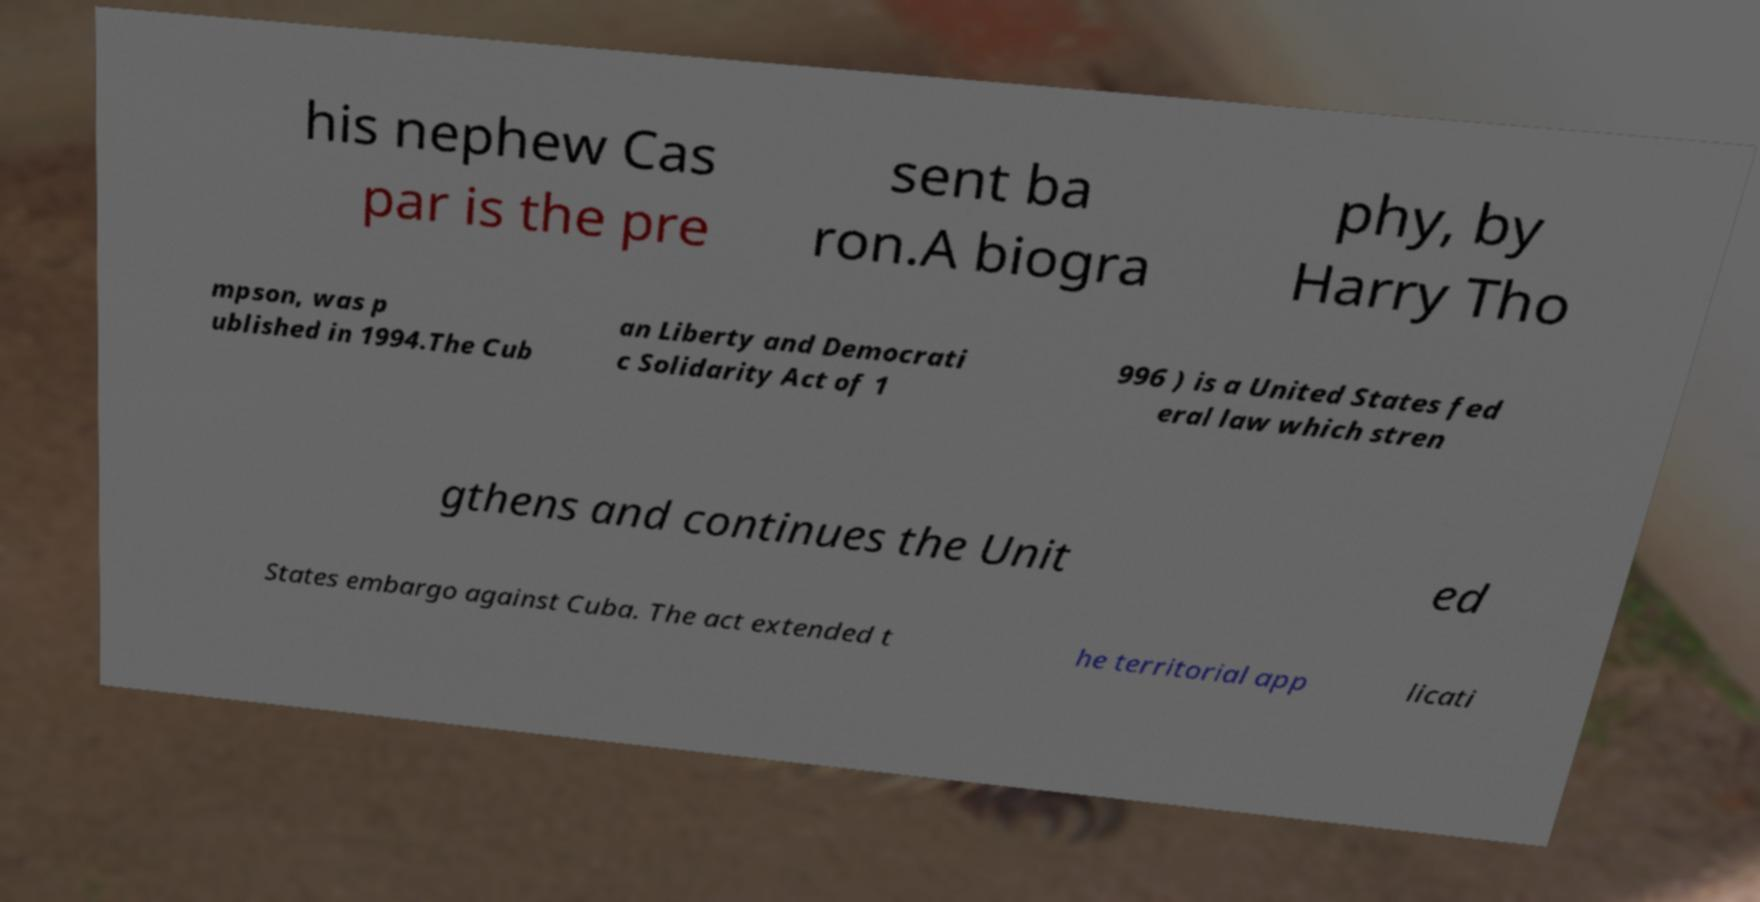Could you extract and type out the text from this image? his nephew Cas par is the pre sent ba ron.A biogra phy, by Harry Tho mpson, was p ublished in 1994.The Cub an Liberty and Democrati c Solidarity Act of 1 996 ) is a United States fed eral law which stren gthens and continues the Unit ed States embargo against Cuba. The act extended t he territorial app licati 